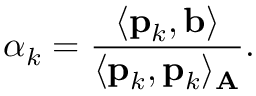Convert formula to latex. <formula><loc_0><loc_0><loc_500><loc_500>\alpha _ { k } = { \frac { \langle p _ { k } , b \rangle } { \langle p _ { k } , p _ { k } \rangle _ { A } } } .</formula> 